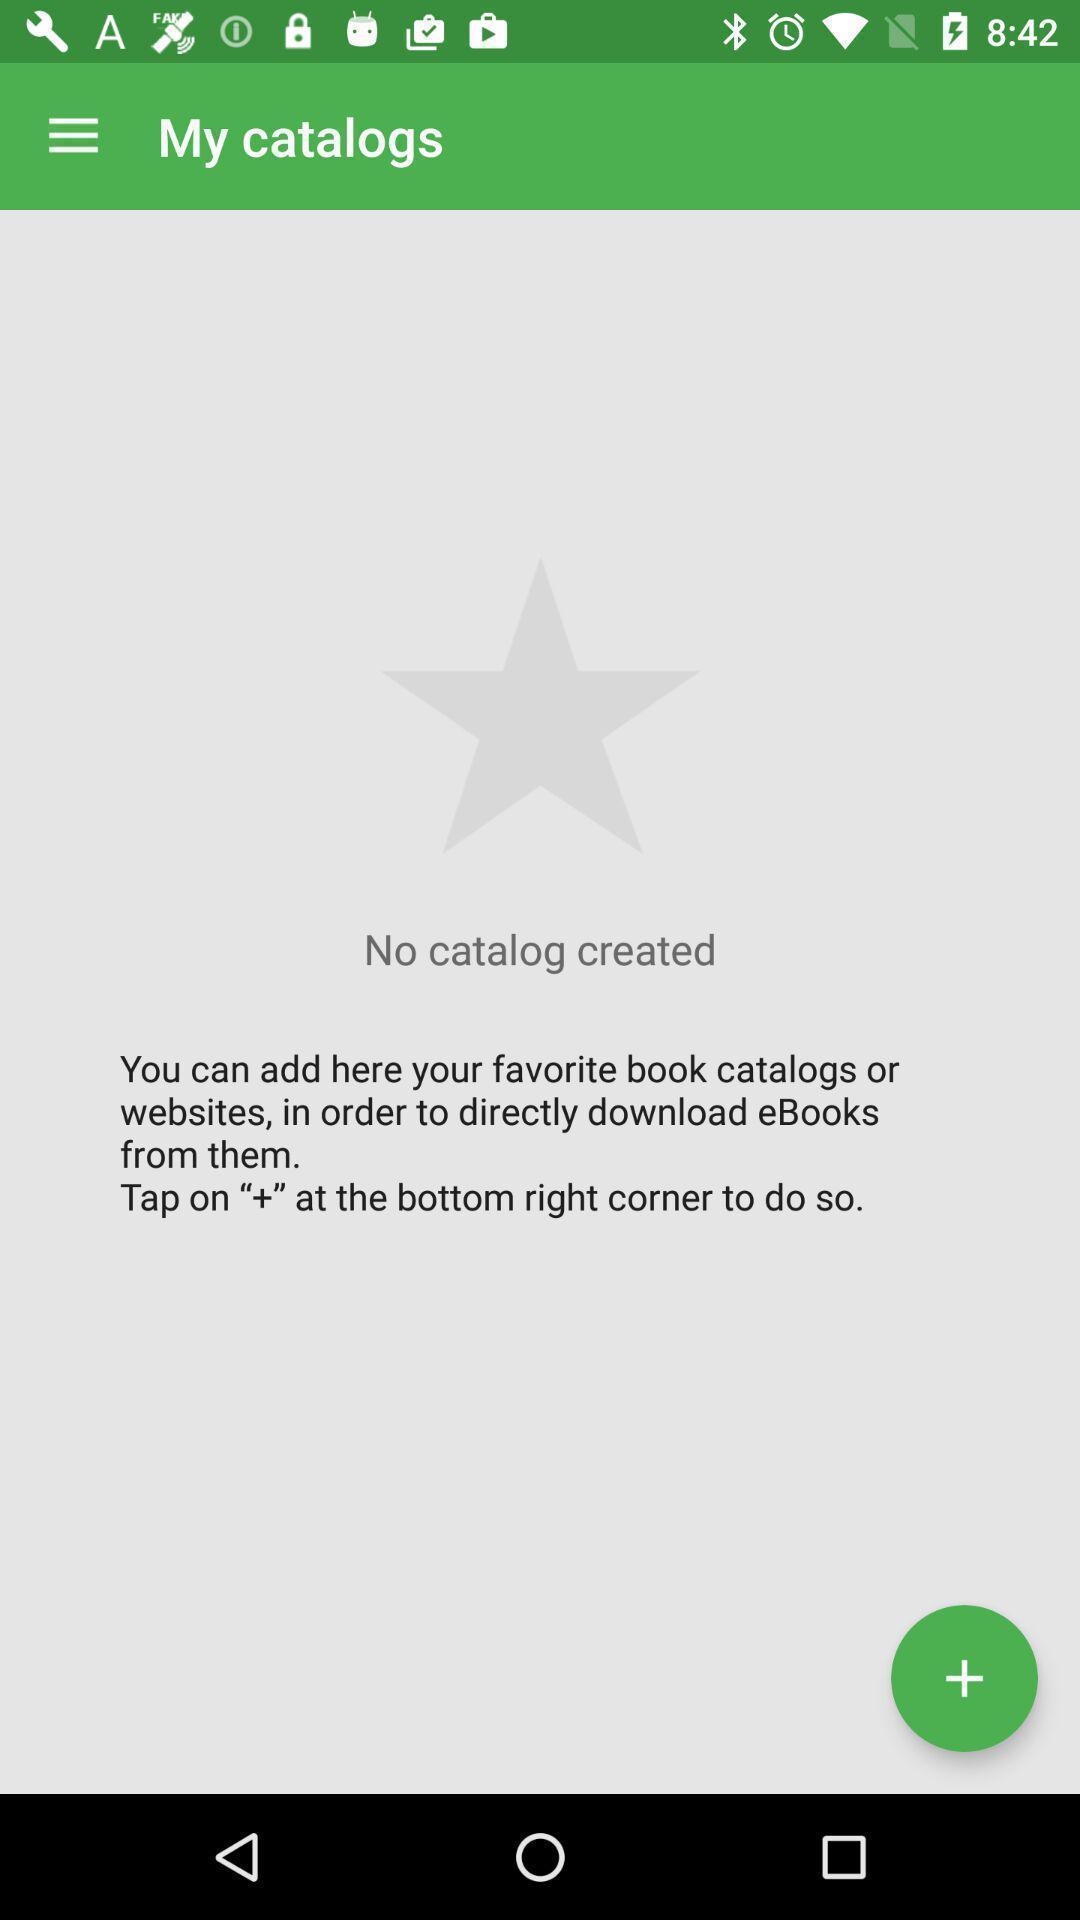Describe the content in this image. Window displaying a ebook app. 